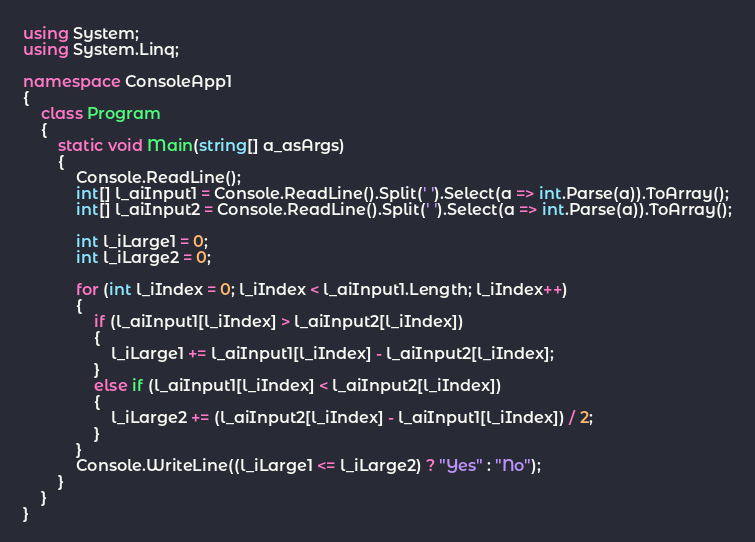Convert code to text. <code><loc_0><loc_0><loc_500><loc_500><_C#_>using System;
using System.Linq;

namespace ConsoleApp1
{
    class Program
    {
        static void Main(string[] a_asArgs)
        {
			Console.ReadLine();
			int[] l_aiInput1 = Console.ReadLine().Split(' ').Select(a => int.Parse(a)).ToArray();
			int[] l_aiInput2 = Console.ReadLine().Split(' ').Select(a => int.Parse(a)).ToArray();

			int l_iLarge1 = 0;
			int l_iLarge2 = 0;

			for (int l_iIndex = 0; l_iIndex < l_aiInput1.Length; l_iIndex++)
			{
				if (l_aiInput1[l_iIndex] > l_aiInput2[l_iIndex])
				{
					l_iLarge1 += l_aiInput1[l_iIndex] - l_aiInput2[l_iIndex];
				}
				else if (l_aiInput1[l_iIndex] < l_aiInput2[l_iIndex])
				{
					l_iLarge2 += (l_aiInput2[l_iIndex] - l_aiInput1[l_iIndex]) / 2;
				}
			}
			Console.WriteLine((l_iLarge1 <= l_iLarge2) ? "Yes" : "No");
		}
	}
}
</code> 